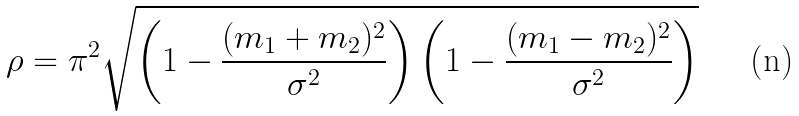Convert formula to latex. <formula><loc_0><loc_0><loc_500><loc_500>\rho = \pi ^ { 2 } \sqrt { \left ( 1 - \frac { ( m _ { 1 } + m _ { 2 } ) ^ { 2 } } { \sigma ^ { 2 } } \right ) \left ( 1 - \frac { ( m _ { 1 } - m _ { 2 } ) ^ { 2 } } { \sigma ^ { 2 } } \right ) }</formula> 